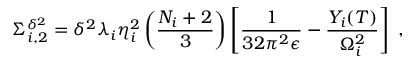Convert formula to latex. <formula><loc_0><loc_0><loc_500><loc_500>\Sigma _ { i , 2 } ^ { \delta ^ { 2 } } = \delta ^ { 2 } \lambda _ { i } \eta _ { i } ^ { 2 } \left ( \frac { N _ { i } + 2 } { 3 } \right ) \left [ \frac { 1 } { 3 2 \pi ^ { 2 } \epsilon } - \frac { Y _ { i } ( T ) } { \Omega _ { i } ^ { 2 } } \right ] \, ,</formula> 